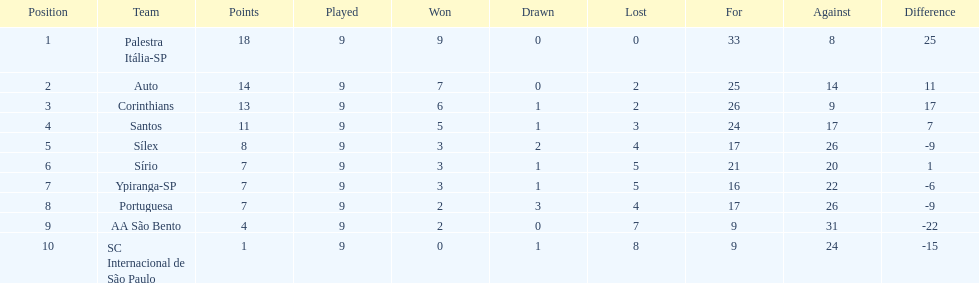Which team was the only team that was undefeated? Palestra Itália-SP. 